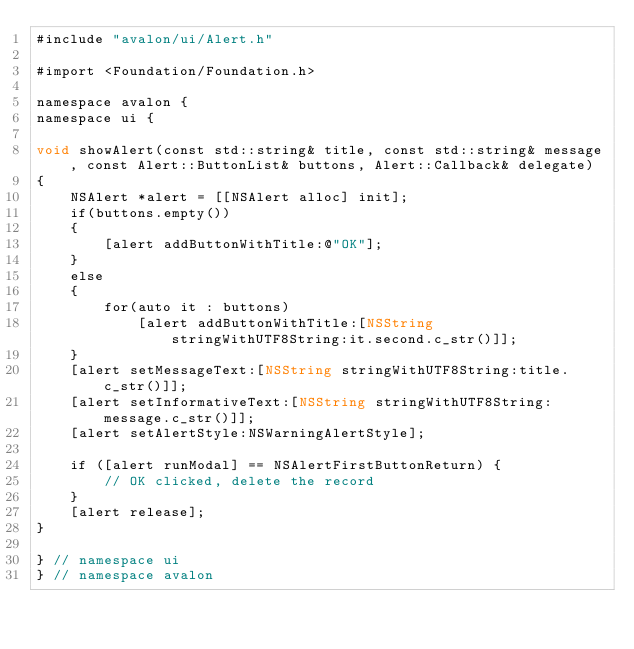Convert code to text. <code><loc_0><loc_0><loc_500><loc_500><_ObjectiveC_>#include "avalon/ui/Alert.h"

#import <Foundation/Foundation.h>

namespace avalon {
namespace ui {

void showAlert(const std::string& title, const std::string& message, const Alert::ButtonList& buttons, Alert::Callback& delegate)
{
    NSAlert *alert = [[NSAlert alloc] init];
    if(buttons.empty())
    {
        [alert addButtonWithTitle:@"OK"];
    }
    else
    {
        for(auto it : buttons)
            [alert addButtonWithTitle:[NSString stringWithUTF8String:it.second.c_str()]];
    }
    [alert setMessageText:[NSString stringWithUTF8String:title.c_str()]];
    [alert setInformativeText:[NSString stringWithUTF8String:message.c_str()]];
    [alert setAlertStyle:NSWarningAlertStyle];
    
    if ([alert runModal] == NSAlertFirstButtonReturn) {
        // OK clicked, delete the record
    }
    [alert release];
}

} // namespace ui
} // namespace avalon</code> 